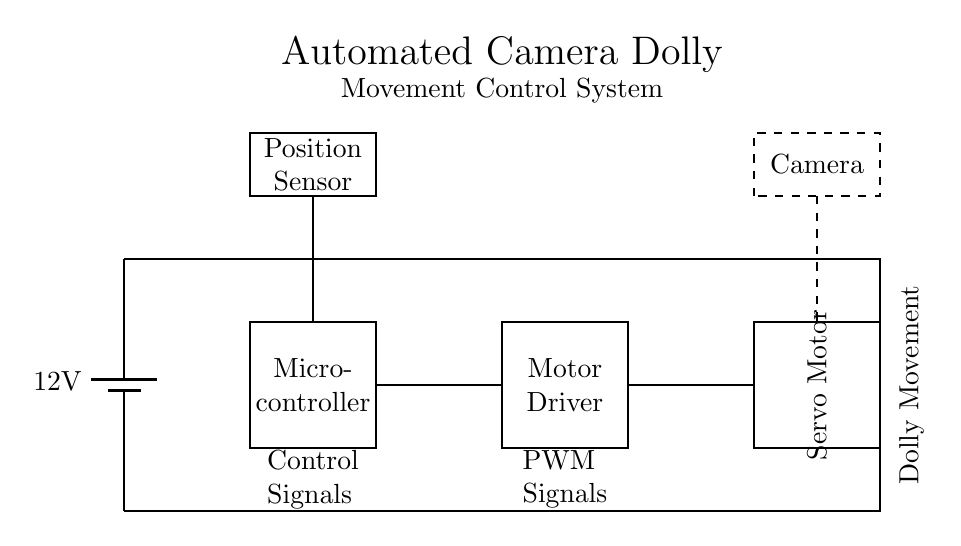What is the voltage of the power supply? The diagram specifies a power supply labeled as a battery with a voltage of 12 volts. This is indicated directly at the component in the diagram.
Answer: 12 volts What component is located between the power supply and the motor driver? The microcontroller is positioned between the power supply and the motor driver. Its placement is indicated by the lines connecting these components, making it clear it receives power before supplying the motor driver.
Answer: Microcontroller How many main components are shown in this circuit? There are four main components: the power supply, microcontroller, motor driver, and servo motor. Each is depicted in rectangular shapes, which simplifies counting.
Answer: Four What type of signal does the motor driver receive from the microcontroller? The motor driver receives PWM signals from the microcontroller. This is indicated by the labeling on the connecting line between these two components.
Answer: PWM signals What is the function of the position sensor in this circuit? The position sensor provides feedback to the microcontroller regarding the current position. This is inferred from its placement and connection to the microcontroller, indicating it is used to adjust movements based on the servo's position.
Answer: Feedback Which component is responsible for dolly movement? The servo motor is responsible for dolly movement. Its labeling in the diagram as "Servo Motor" and its connection to the motor driver shows it is the actuator for movement control.
Answer: Servo motor What is the type of control used to adjust the servo motor? PWM control is used to adjust the servo motor. This can be understood through the labeling of the connections and the purpose of the components in the circuit, as PWM is commonly used for controlling servo motors.
Answer: PWM control 